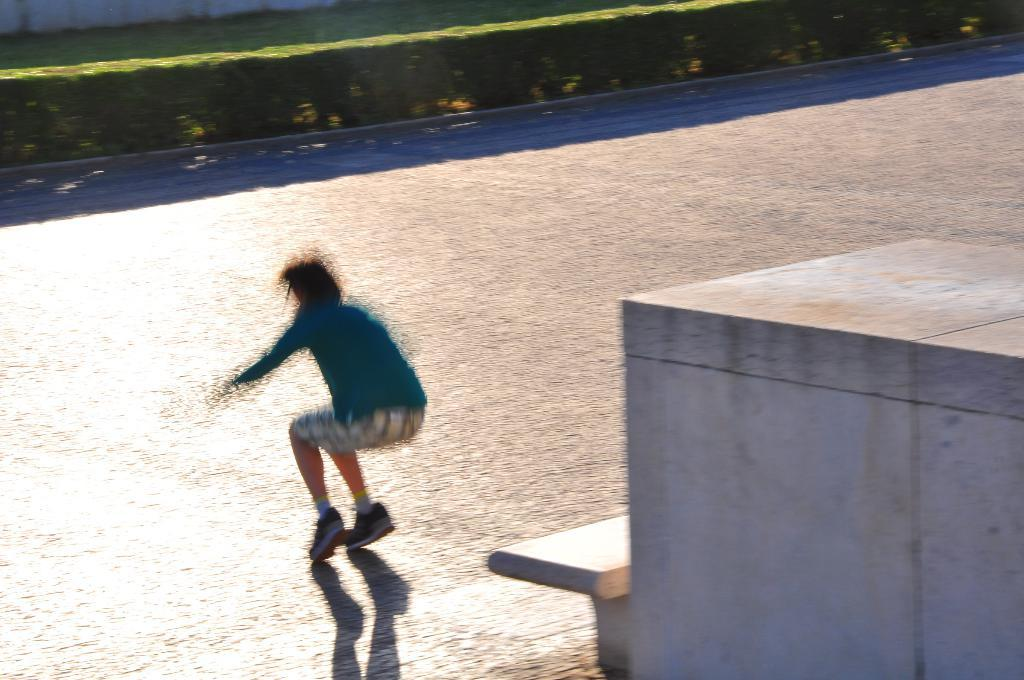What type of seating is present in the image? There is a bench in the image. Who or what is present on the bench? There is a person in the image. What can be observed about the lighting in the image? Shadows are visible in the image. What type of clothing is the person wearing on their lower body? The person is wearing shorts. What type of footwear is the person wearing? The person is wearing shoes. What color is the dress that the person is wearing? The person is wearing a blue color dress. Is the queen present in the image, and if so, what is she doing? There is no queen present in the image. Can you hear the person in the image crying? The image is silent, and there is no indication of the person crying. 